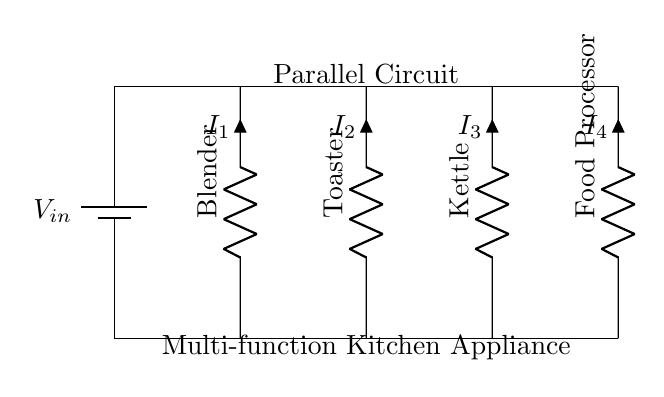What type of circuit is depicted? The diagram shows a parallel circuit, which can be identified by multiple components connected across the same voltage source.
Answer: Parallel circuit What components are present in the circuit? The circuit includes a blender, toaster, kettle, and food processor, which are all represented as resistive loads by the symbols used.
Answer: Blender, toaster, kettle, food processor What is the voltage across each component? Each component in a parallel circuit has the same voltage as the source. Thus, the voltage across each heating element is equal to the supplied input voltage.
Answer: V in Which component has the highest current? To determine which has the highest current, we consider the resistance and apply Ohm's law. However, without values, we can't determine which component draws more current explicitly.
Answer: Not determinable without values What happens to the other components if one is turned off? In a parallel circuit, if one component is turned off, the others stay powered because they all connect independently to the voltage source.
Answer: Others stay powered How many branches does this circuit have? The circuit diagram has four components, indicating that there are four separate branches connected in parallel to the power source.
Answer: Four What is the total current in this circuit? The total current in a parallel circuit is the sum of the currents through each branch. Each component's current can be different, so the total would be cumulative.
Answer: Sum of individual currents 